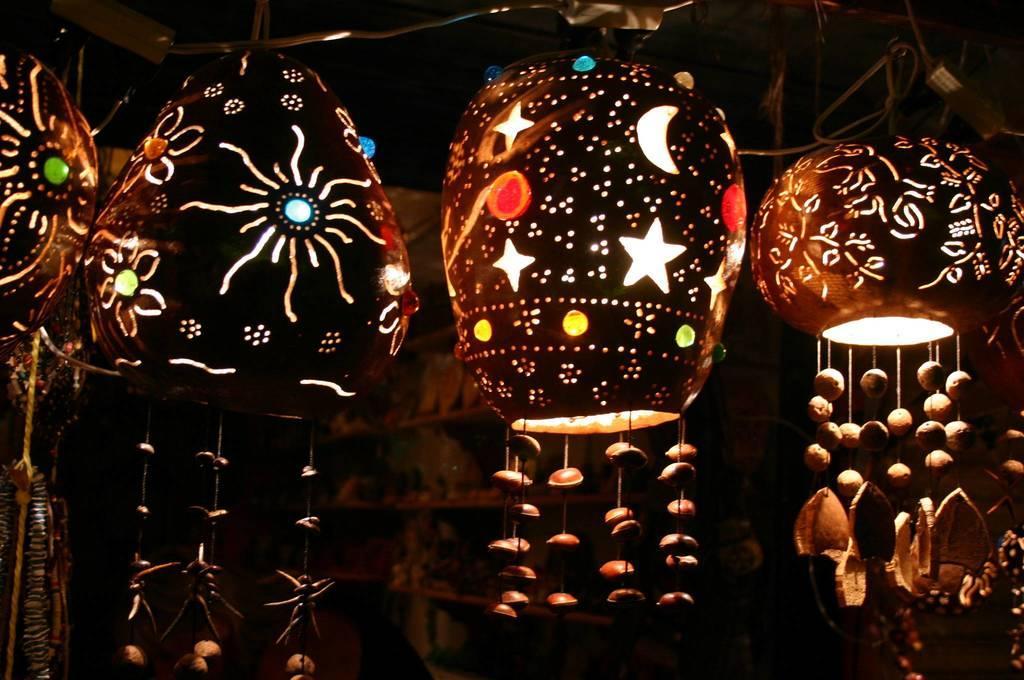Please provide a concise description of this image. In the image in the center, we can see few paper lanterns. In the background there is a wall, roof, shelf and a few other objects. 